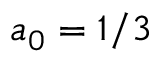<formula> <loc_0><loc_0><loc_500><loc_500>a _ { 0 } = 1 / 3</formula> 